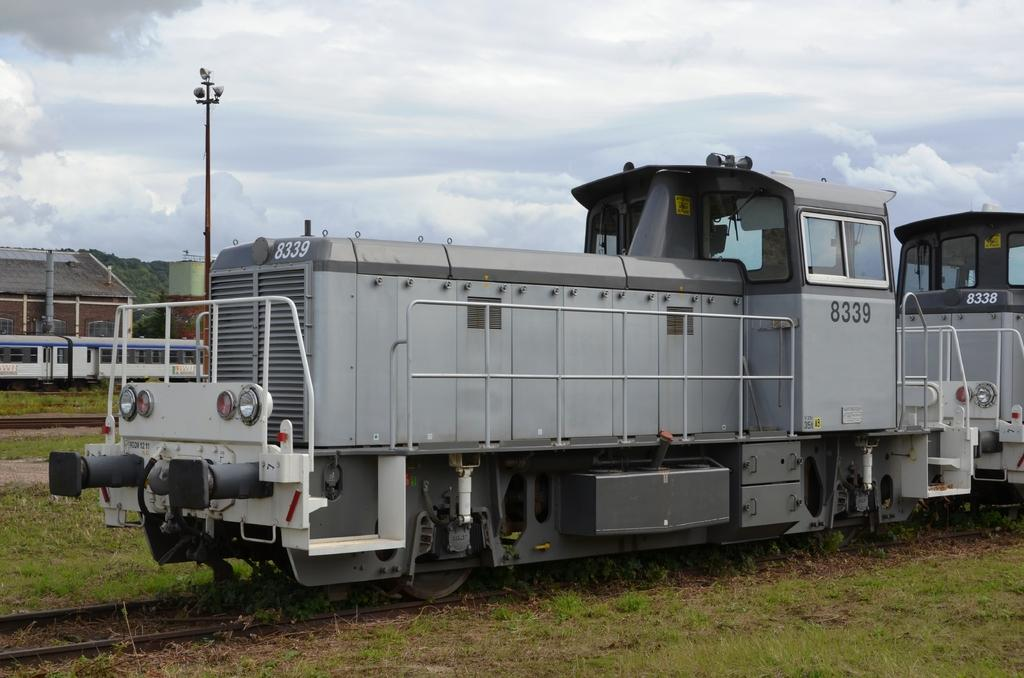What type of vehicles can be seen on the railway track in the image? There are trains on the railway track in the image. What type of vegetation is visible in the image? There is grass visible in the image. What structure can be seen in the image that provides light? There is a light pole in the image. What type of buildings can be seen in the image? There are houses in the image. What part of the natural environment is visible in the image? The sky is visible in the image. What can be seen in the sky in the image? Clouds are present in the sky. How many snails can be seen crawling on the tray in the image? There is no tray or snails present in the image. What type of clouds are depicted in the image? The provided facts do not specify the type of clouds; only their presence is mentioned. 